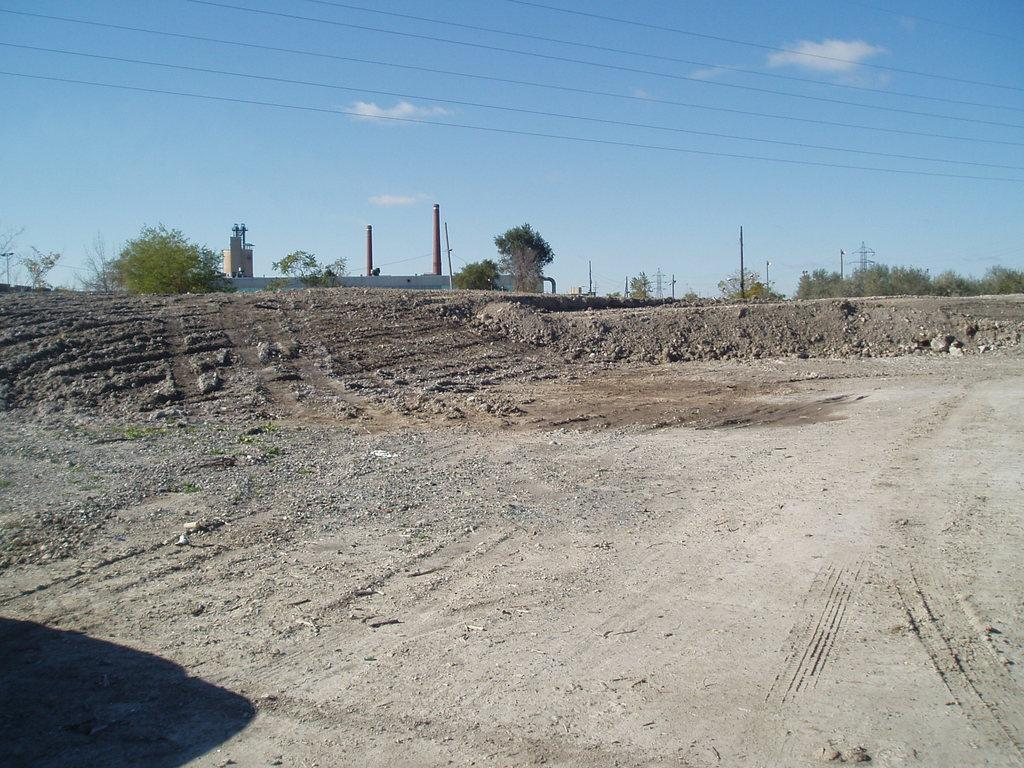What structures are present in the image? There are towers and a building in the image. What type of vegetation can be seen in the image? There are trees in the image. What else is visible in the image besides the structures and vegetation? Cables are visible in the image. What type of fang can be seen in the image? There is no fang present in the image. Is there any indication of a war happening in the image? There is no indication of a war in the image. 